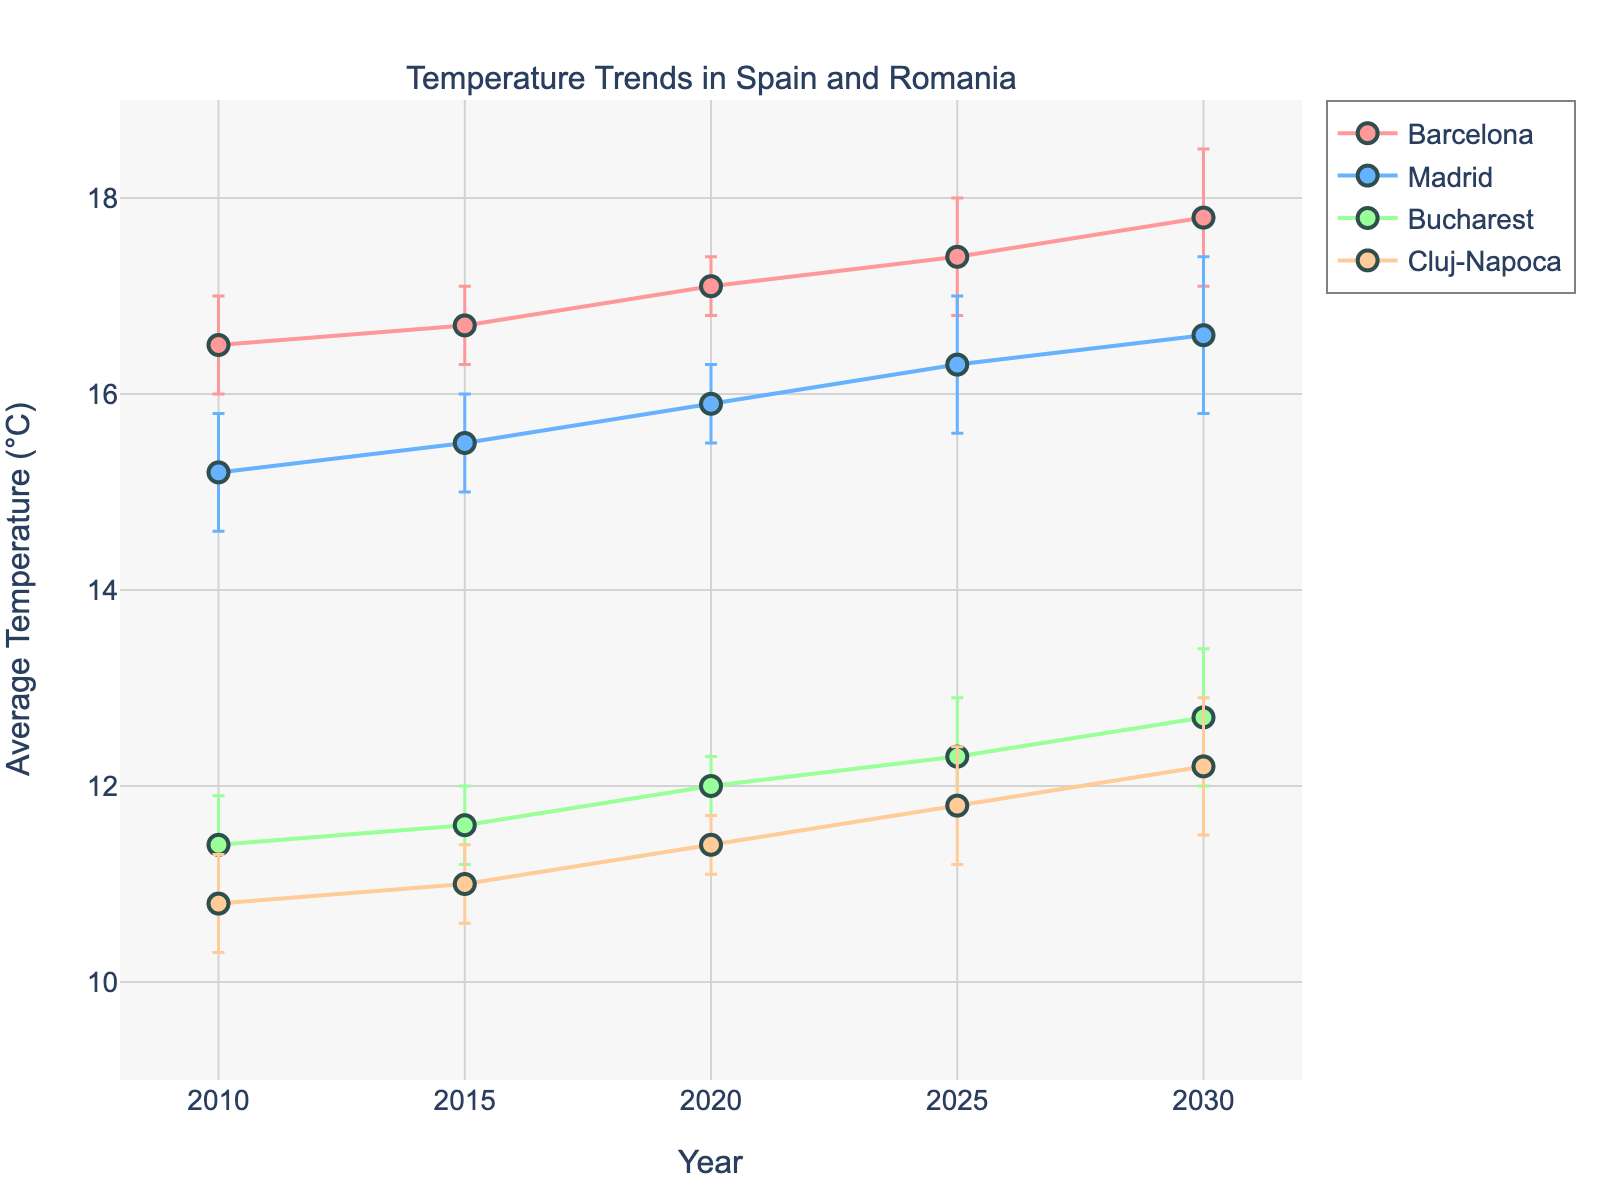What's the title of the figure? The title is written at the top of the figure and says "Temperature Trends in Spain and Romania".
Answer: Temperature Trends in Spain and Romania What is the y-axis label? The label for the y-axis, found alongside the vertical axis, indicates the units of measurement for the data and says "Average Temperature (°C)".
Answer: Average Temperature (°C) How does the average temperature of Bucharest in 2020 compare to that of Barcelona in 2020? Look at the y-axis values corresponding to 2020 for both Bucharest and Barcelona. Bucharest's average temperature is approximately 12.0°C, while Barcelona's is about 17.1°C. Therefore, Barcelona's average temperature is higher.
Answer: Barcelona is higher How is the temperature uncertainty depicted for Madrid in 2030? The uncertainty is shown using error bars extending from the data points. For Madrid in 2030, the error bars stretch above and below the point at 16.6°C.
Answer: Error bars What is the trend in the average temperature for Cluj-Napoca from 2010 to 2030? Look at the data points for Cluj-Napoca over the years. The temperature increases from around 10.8°C in 2010 to about 12.2°C in 2030, showing an upward trend.
Answer: Increasing Which city has the smallest uncertainty in temperature estimates in 2015? Compare the lengths of the error bars for each city in 2015. Barcelona has the shortest error bar of approximately 0.4°C.
Answer: Barcelona What is the difference in average temperature between Madrid in 2025 and Cluj-Napoca in 2025? Look at the y-axis values for Madrid and Cluj-Napoca in 2025. Madrid's average temperature is approximately 16.3°C, and Cluj-Napoca's is around 11.8°C. The difference is 16.3 - 11.8 = 4.5°C.
Answer: 4.5°C What’s the average temperature of Barcelona for the years shown? Sum the temperatures for Barcelona for 2010, 2015, 2020, 2025, and 2030 and divide by the number of years. (16.5 + 16.7 + 17.1 + 17.4 + 17.8) / 5 = 17.1°C
Answer: 17.1°C Which city shows the largest increase in average temperature from 2010 to 2030? Compare the temperature values of each city for 2010 and 2030. Calculate the differences: Barcelona (1.3°C), Madrid (1.4°C), Bucharest (1.3°C), Cluj-Napoca (1.4°C). Madrid and Cluj-Napoca both have the largest increase of 1.4°C.
Answer: Madrid and Cluj-Napoca 